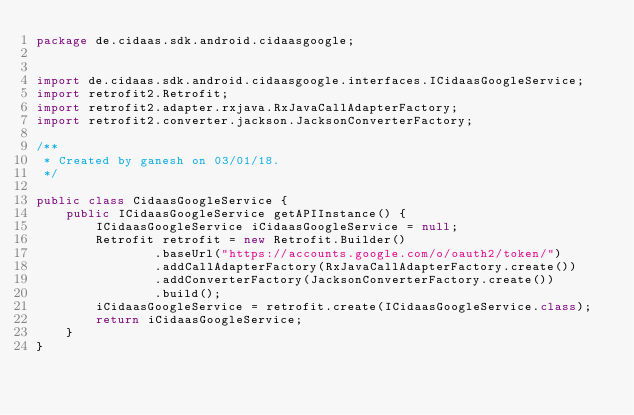<code> <loc_0><loc_0><loc_500><loc_500><_Java_>package de.cidaas.sdk.android.cidaasgoogle;


import de.cidaas.sdk.android.cidaasgoogle.interfaces.ICidaasGoogleService;
import retrofit2.Retrofit;
import retrofit2.adapter.rxjava.RxJavaCallAdapterFactory;
import retrofit2.converter.jackson.JacksonConverterFactory;

/**
 * Created by ganesh on 03/01/18.
 */

public class CidaasGoogleService {
    public ICidaasGoogleService getAPIInstance() {
        ICidaasGoogleService iCidaasGoogleService = null;
        Retrofit retrofit = new Retrofit.Builder()
                .baseUrl("https://accounts.google.com/o/oauth2/token/")
                .addCallAdapterFactory(RxJavaCallAdapterFactory.create())
                .addConverterFactory(JacksonConverterFactory.create())
                .build();
        iCidaasGoogleService = retrofit.create(ICidaasGoogleService.class);
        return iCidaasGoogleService;
    }
}</code> 